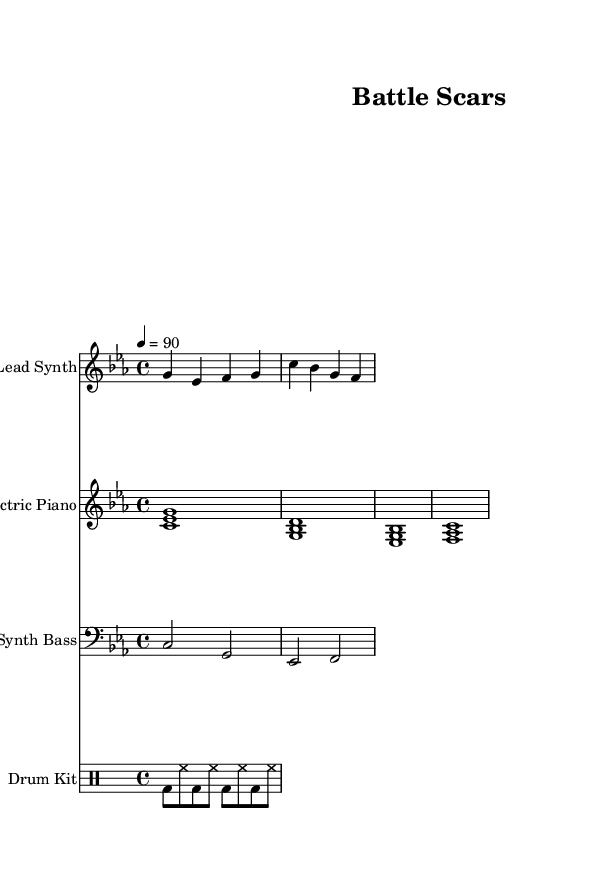What is the key signature of this music? The key signature is indicated at the beginning of the score, showing three flats, which corresponds to C minor.
Answer: C minor What is the time signature of this music? The time signature is also found at the beginning of the score, represented as 4/4, meaning four beats per measure and a quarter note receives one beat.
Answer: 4/4 What is the tempo marking for the music? The tempo is indicated in beats per minute, shown as 4 = 90, meaning the quarter note should be played at 90 beats per minute.
Answer: 90 How many verses are present in the lyrics? By counting the distinct sections labeled as lyrics in the score, there are two sections for lyrics, indicating one verse followed by a chorus.
Answer: 1 What instrument is the lead synth written for? The lead synth part is scored for the treble clef, indicating it is played by an instrument that reads from this clef, typically a keyboard or synthesizer.
Answer: Lead Synth What are the first three words of the verse? The verse lyrics start with "Back from the," which is evident in the section labeled as 'verse' beneath the lead synth staff.
Answer: Back from the What type of rhythm does the drum pattern suggest? The drum pattern consists of bass drum (bd) and hi-hat (hh) beats in eighth notes, which contributes to a driving, energetic feel commonly found in hard-hitting rap music.
Answer: Driving rhythm 